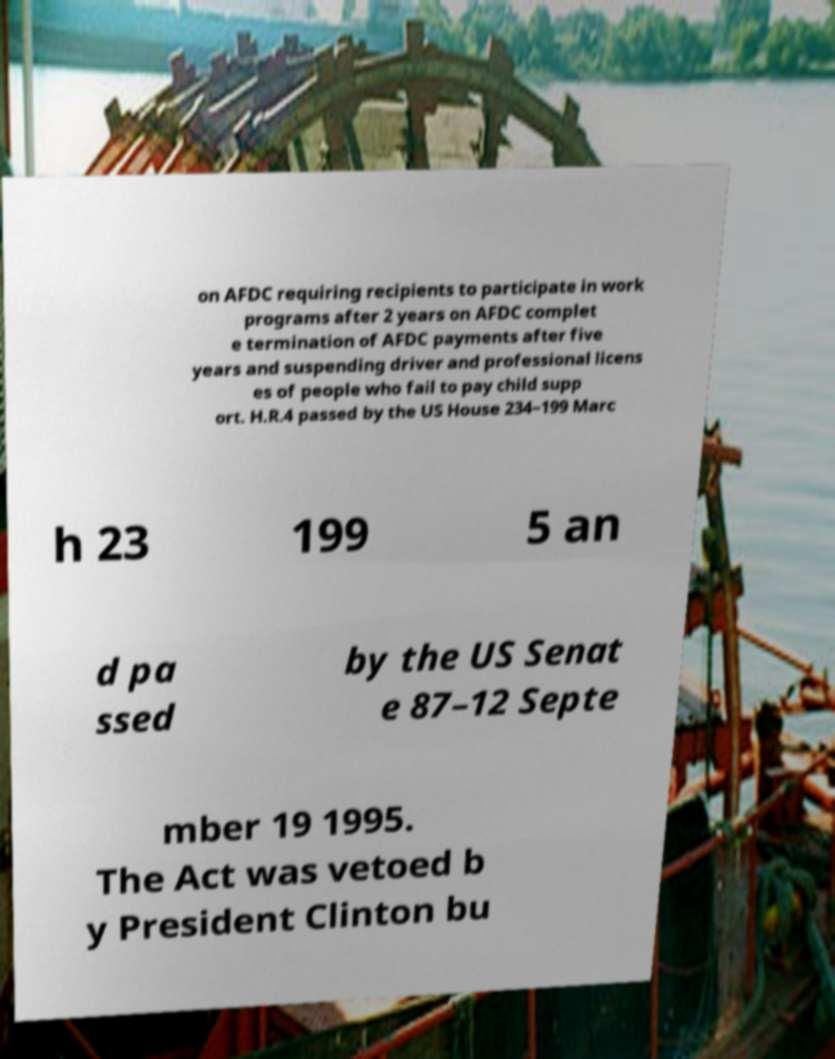There's text embedded in this image that I need extracted. Can you transcribe it verbatim? on AFDC requiring recipients to participate in work programs after 2 years on AFDC complet e termination of AFDC payments after five years and suspending driver and professional licens es of people who fail to pay child supp ort. H.R.4 passed by the US House 234–199 Marc h 23 199 5 an d pa ssed by the US Senat e 87–12 Septe mber 19 1995. The Act was vetoed b y President Clinton bu 